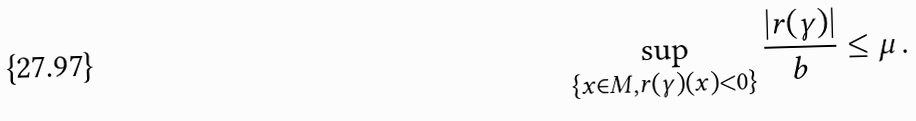<formula> <loc_0><loc_0><loc_500><loc_500>\sup _ { \{ x \in M , r ( \gamma ) ( x ) < 0 \} } \frac { | r ( \gamma ) | } { b } \leq \mu \, .</formula> 